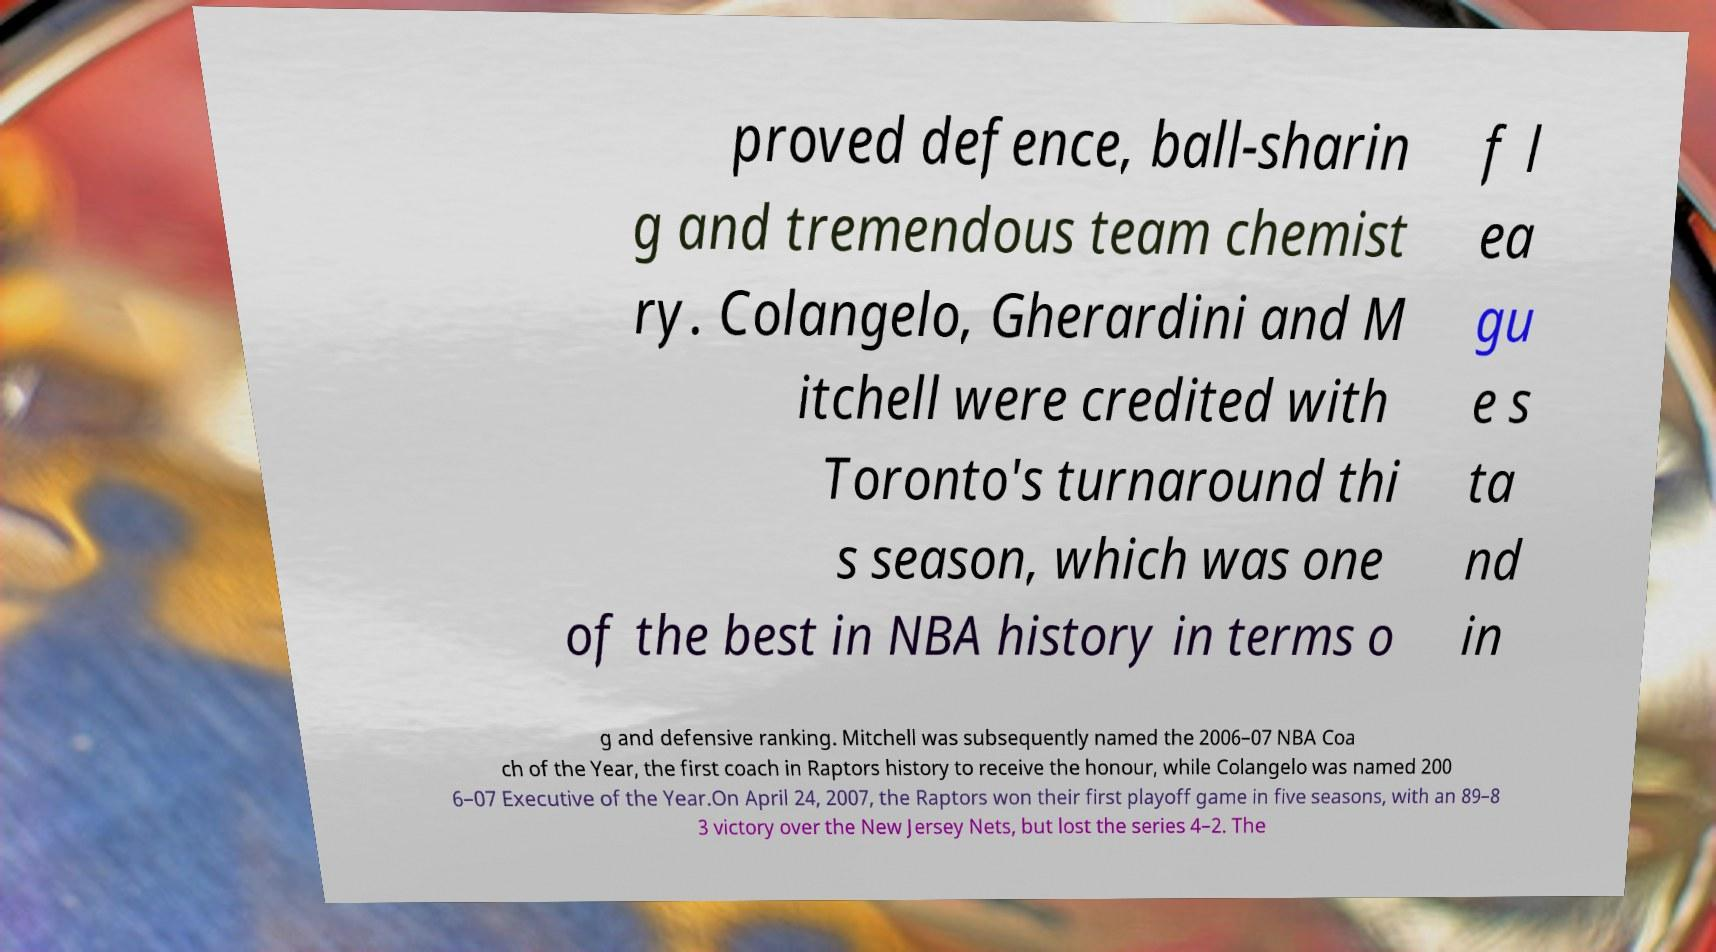Please identify and transcribe the text found in this image. proved defence, ball-sharin g and tremendous team chemist ry. Colangelo, Gherardini and M itchell were credited with Toronto's turnaround thi s season, which was one of the best in NBA history in terms o f l ea gu e s ta nd in g and defensive ranking. Mitchell was subsequently named the 2006–07 NBA Coa ch of the Year, the first coach in Raptors history to receive the honour, while Colangelo was named 200 6–07 Executive of the Year.On April 24, 2007, the Raptors won their first playoff game in five seasons, with an 89–8 3 victory over the New Jersey Nets, but lost the series 4–2. The 